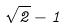Convert formula to latex. <formula><loc_0><loc_0><loc_500><loc_500>\sqrt { 2 } - 1</formula> 